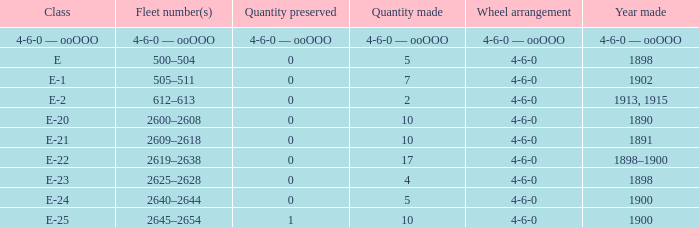What is the quantity preserved of the e-1 class? 0.0. 